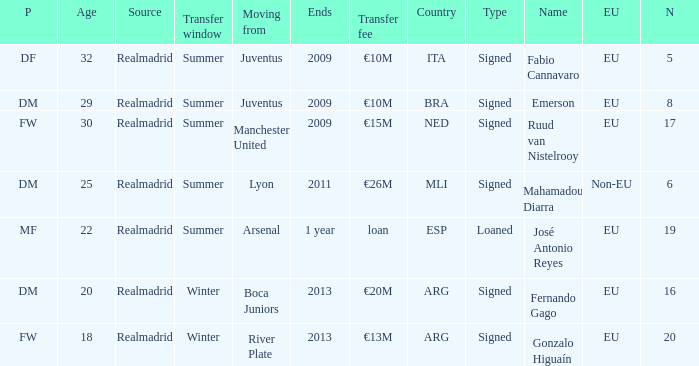What kind of player had a transfer fee of €20m? Signed. 